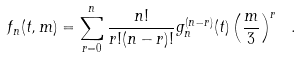Convert formula to latex. <formula><loc_0><loc_0><loc_500><loc_500>f _ { n } ( t , m ) = \sum _ { r = 0 } ^ { n } \frac { n ! } { r ! ( n - r ) ! } g _ { n } ^ { ( n - r ) } ( t ) \left ( \frac { m } { 3 } \right ) ^ { r } \ .</formula> 